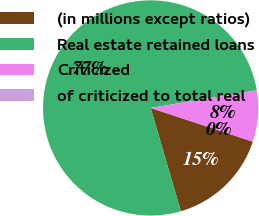<chart> <loc_0><loc_0><loc_500><loc_500><pie_chart><fcel>(in millions except ratios)<fcel>Real estate retained loans<fcel>Criticized<fcel>of criticized to total real<nl><fcel>15.39%<fcel>76.92%<fcel>7.69%<fcel>0.0%<nl></chart> 